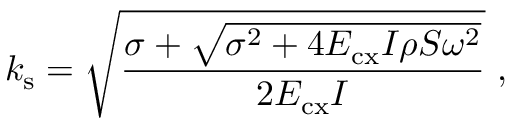<formula> <loc_0><loc_0><loc_500><loc_500>k _ { s } = \sqrt { \frac { \sigma + \sqrt { \sigma ^ { 2 } + 4 E _ { c x } I \rho S \omega ^ { 2 } } } { 2 E _ { c x } I } } ,</formula> 